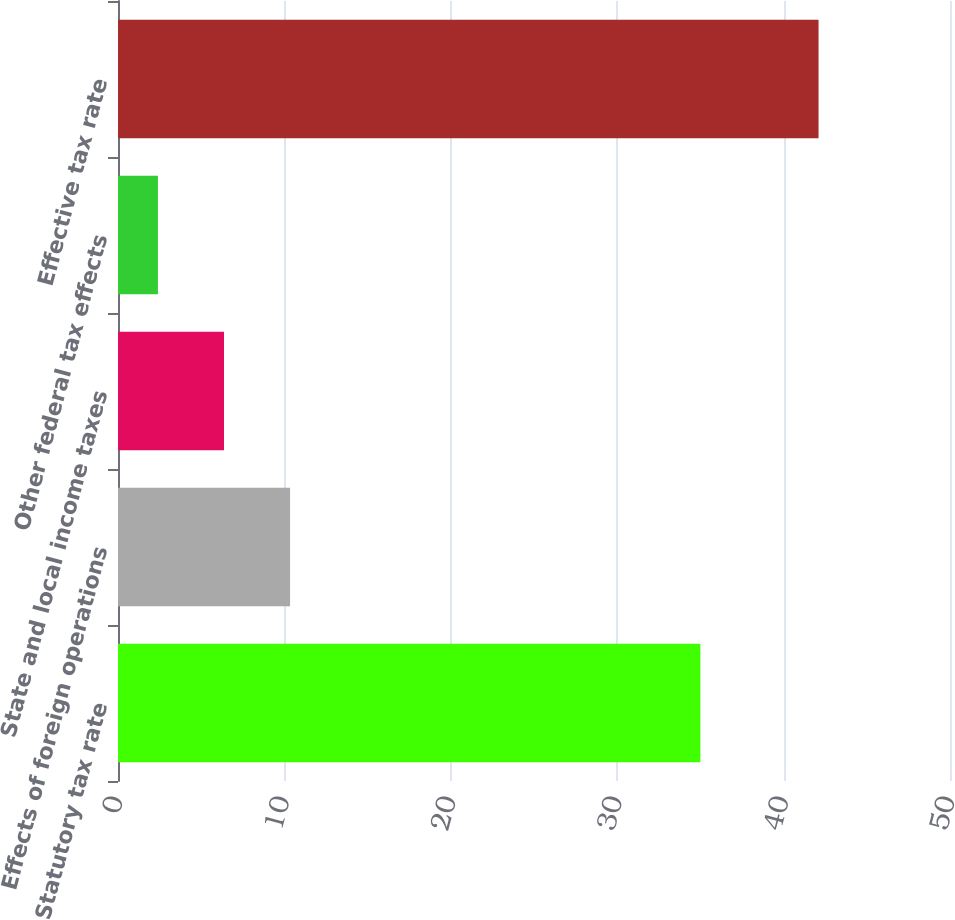Convert chart to OTSL. <chart><loc_0><loc_0><loc_500><loc_500><bar_chart><fcel>Statutory tax rate<fcel>Effects of foreign operations<fcel>State and local income taxes<fcel>Other federal tax effects<fcel>Effective tax rate<nl><fcel>35<fcel>10.34<fcel>6.37<fcel>2.4<fcel>42.1<nl></chart> 